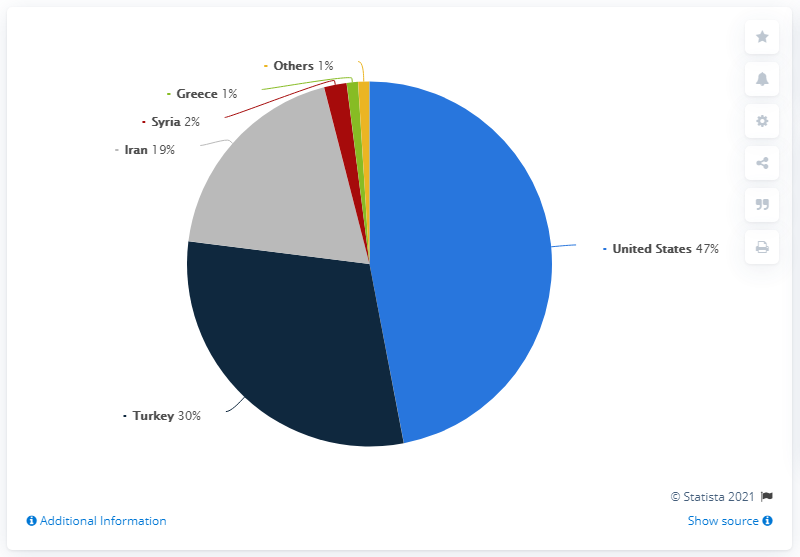Point out several critical features in this image. According to the latest data, the combined share of pistachio production of Turkey and Iran in worldwide production in 2020/2021 was 49%. Based on the most recent data, the United States has the highest share in the production of pistachios worldwide in 2020/2021. 